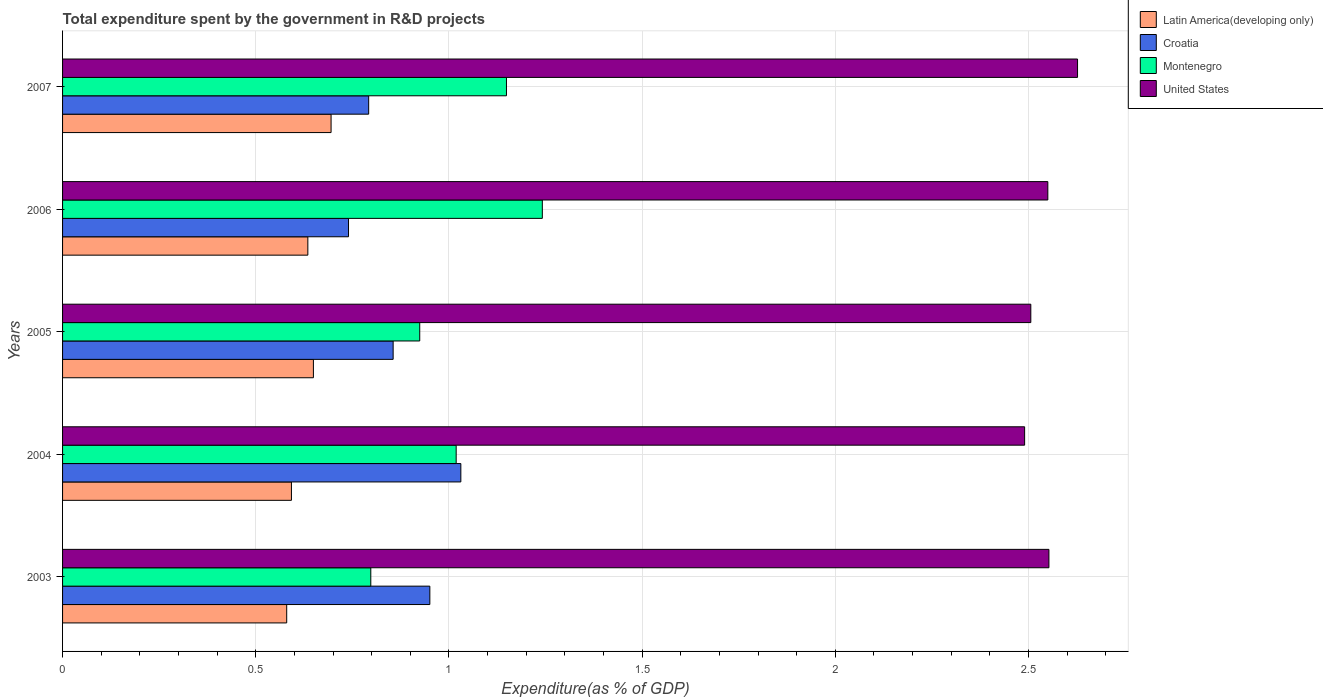How many different coloured bars are there?
Your answer should be compact. 4. How many groups of bars are there?
Provide a short and direct response. 5. Are the number of bars per tick equal to the number of legend labels?
Offer a terse response. Yes. How many bars are there on the 4th tick from the bottom?
Your answer should be compact. 4. In how many cases, is the number of bars for a given year not equal to the number of legend labels?
Provide a succinct answer. 0. What is the total expenditure spent by the government in R&D projects in United States in 2006?
Your answer should be very brief. 2.55. Across all years, what is the maximum total expenditure spent by the government in R&D projects in Croatia?
Give a very brief answer. 1.03. Across all years, what is the minimum total expenditure spent by the government in R&D projects in Croatia?
Make the answer very short. 0.74. In which year was the total expenditure spent by the government in R&D projects in Latin America(developing only) maximum?
Offer a very short reply. 2007. What is the total total expenditure spent by the government in R&D projects in Montenegro in the graph?
Ensure brevity in your answer.  5.13. What is the difference between the total expenditure spent by the government in R&D projects in Latin America(developing only) in 2006 and that in 2007?
Provide a short and direct response. -0.06. What is the difference between the total expenditure spent by the government in R&D projects in Croatia in 2006 and the total expenditure spent by the government in R&D projects in Montenegro in 2003?
Keep it short and to the point. -0.06. What is the average total expenditure spent by the government in R&D projects in Montenegro per year?
Offer a terse response. 1.03. In the year 2006, what is the difference between the total expenditure spent by the government in R&D projects in Latin America(developing only) and total expenditure spent by the government in R&D projects in Montenegro?
Provide a short and direct response. -0.61. What is the ratio of the total expenditure spent by the government in R&D projects in Croatia in 2003 to that in 2006?
Provide a short and direct response. 1.28. Is the difference between the total expenditure spent by the government in R&D projects in Latin America(developing only) in 2004 and 2007 greater than the difference between the total expenditure spent by the government in R&D projects in Montenegro in 2004 and 2007?
Keep it short and to the point. Yes. What is the difference between the highest and the second highest total expenditure spent by the government in R&D projects in Montenegro?
Give a very brief answer. 0.09. What is the difference between the highest and the lowest total expenditure spent by the government in R&D projects in Latin America(developing only)?
Your answer should be very brief. 0.11. In how many years, is the total expenditure spent by the government in R&D projects in Latin America(developing only) greater than the average total expenditure spent by the government in R&D projects in Latin America(developing only) taken over all years?
Ensure brevity in your answer.  3. Is the sum of the total expenditure spent by the government in R&D projects in United States in 2006 and 2007 greater than the maximum total expenditure spent by the government in R&D projects in Montenegro across all years?
Give a very brief answer. Yes. What does the 4th bar from the top in 2004 represents?
Offer a terse response. Latin America(developing only). What does the 3rd bar from the bottom in 2006 represents?
Ensure brevity in your answer.  Montenegro. Is it the case that in every year, the sum of the total expenditure spent by the government in R&D projects in Montenegro and total expenditure spent by the government in R&D projects in Latin America(developing only) is greater than the total expenditure spent by the government in R&D projects in Croatia?
Your answer should be compact. Yes. How many bars are there?
Offer a very short reply. 20. Are all the bars in the graph horizontal?
Give a very brief answer. Yes. How many years are there in the graph?
Provide a succinct answer. 5. Does the graph contain any zero values?
Provide a short and direct response. No. Does the graph contain grids?
Give a very brief answer. Yes. Where does the legend appear in the graph?
Give a very brief answer. Top right. What is the title of the graph?
Make the answer very short. Total expenditure spent by the government in R&D projects. What is the label or title of the X-axis?
Ensure brevity in your answer.  Expenditure(as % of GDP). What is the label or title of the Y-axis?
Your answer should be very brief. Years. What is the Expenditure(as % of GDP) of Latin America(developing only) in 2003?
Your answer should be compact. 0.58. What is the Expenditure(as % of GDP) of Croatia in 2003?
Offer a very short reply. 0.95. What is the Expenditure(as % of GDP) in Montenegro in 2003?
Offer a terse response. 0.8. What is the Expenditure(as % of GDP) in United States in 2003?
Offer a very short reply. 2.55. What is the Expenditure(as % of GDP) of Latin America(developing only) in 2004?
Your response must be concise. 0.59. What is the Expenditure(as % of GDP) of Croatia in 2004?
Make the answer very short. 1.03. What is the Expenditure(as % of GDP) of Montenegro in 2004?
Keep it short and to the point. 1.02. What is the Expenditure(as % of GDP) in United States in 2004?
Give a very brief answer. 2.49. What is the Expenditure(as % of GDP) of Latin America(developing only) in 2005?
Ensure brevity in your answer.  0.65. What is the Expenditure(as % of GDP) in Croatia in 2005?
Make the answer very short. 0.86. What is the Expenditure(as % of GDP) in Montenegro in 2005?
Ensure brevity in your answer.  0.92. What is the Expenditure(as % of GDP) in United States in 2005?
Offer a terse response. 2.51. What is the Expenditure(as % of GDP) of Latin America(developing only) in 2006?
Your response must be concise. 0.63. What is the Expenditure(as % of GDP) in Croatia in 2006?
Offer a terse response. 0.74. What is the Expenditure(as % of GDP) of Montenegro in 2006?
Ensure brevity in your answer.  1.24. What is the Expenditure(as % of GDP) in United States in 2006?
Make the answer very short. 2.55. What is the Expenditure(as % of GDP) in Latin America(developing only) in 2007?
Offer a very short reply. 0.69. What is the Expenditure(as % of GDP) in Croatia in 2007?
Provide a succinct answer. 0.79. What is the Expenditure(as % of GDP) in Montenegro in 2007?
Your answer should be compact. 1.15. What is the Expenditure(as % of GDP) in United States in 2007?
Provide a short and direct response. 2.63. Across all years, what is the maximum Expenditure(as % of GDP) in Latin America(developing only)?
Offer a very short reply. 0.69. Across all years, what is the maximum Expenditure(as % of GDP) in Croatia?
Your response must be concise. 1.03. Across all years, what is the maximum Expenditure(as % of GDP) in Montenegro?
Make the answer very short. 1.24. Across all years, what is the maximum Expenditure(as % of GDP) in United States?
Ensure brevity in your answer.  2.63. Across all years, what is the minimum Expenditure(as % of GDP) in Latin America(developing only)?
Give a very brief answer. 0.58. Across all years, what is the minimum Expenditure(as % of GDP) in Croatia?
Provide a succinct answer. 0.74. Across all years, what is the minimum Expenditure(as % of GDP) in Montenegro?
Ensure brevity in your answer.  0.8. Across all years, what is the minimum Expenditure(as % of GDP) of United States?
Ensure brevity in your answer.  2.49. What is the total Expenditure(as % of GDP) of Latin America(developing only) in the graph?
Your answer should be very brief. 3.15. What is the total Expenditure(as % of GDP) of Croatia in the graph?
Give a very brief answer. 4.37. What is the total Expenditure(as % of GDP) of Montenegro in the graph?
Offer a very short reply. 5.13. What is the total Expenditure(as % of GDP) of United States in the graph?
Your answer should be very brief. 12.73. What is the difference between the Expenditure(as % of GDP) of Latin America(developing only) in 2003 and that in 2004?
Offer a very short reply. -0.01. What is the difference between the Expenditure(as % of GDP) in Croatia in 2003 and that in 2004?
Provide a short and direct response. -0.08. What is the difference between the Expenditure(as % of GDP) in Montenegro in 2003 and that in 2004?
Your answer should be compact. -0.22. What is the difference between the Expenditure(as % of GDP) of United States in 2003 and that in 2004?
Offer a terse response. 0.06. What is the difference between the Expenditure(as % of GDP) in Latin America(developing only) in 2003 and that in 2005?
Keep it short and to the point. -0.07. What is the difference between the Expenditure(as % of GDP) in Croatia in 2003 and that in 2005?
Give a very brief answer. 0.1. What is the difference between the Expenditure(as % of GDP) in Montenegro in 2003 and that in 2005?
Provide a short and direct response. -0.13. What is the difference between the Expenditure(as % of GDP) of United States in 2003 and that in 2005?
Ensure brevity in your answer.  0.05. What is the difference between the Expenditure(as % of GDP) of Latin America(developing only) in 2003 and that in 2006?
Provide a short and direct response. -0.05. What is the difference between the Expenditure(as % of GDP) in Croatia in 2003 and that in 2006?
Provide a short and direct response. 0.21. What is the difference between the Expenditure(as % of GDP) in Montenegro in 2003 and that in 2006?
Provide a succinct answer. -0.44. What is the difference between the Expenditure(as % of GDP) of United States in 2003 and that in 2006?
Make the answer very short. 0. What is the difference between the Expenditure(as % of GDP) of Latin America(developing only) in 2003 and that in 2007?
Provide a short and direct response. -0.11. What is the difference between the Expenditure(as % of GDP) of Croatia in 2003 and that in 2007?
Ensure brevity in your answer.  0.16. What is the difference between the Expenditure(as % of GDP) of Montenegro in 2003 and that in 2007?
Provide a short and direct response. -0.35. What is the difference between the Expenditure(as % of GDP) of United States in 2003 and that in 2007?
Make the answer very short. -0.07. What is the difference between the Expenditure(as % of GDP) in Latin America(developing only) in 2004 and that in 2005?
Your answer should be very brief. -0.06. What is the difference between the Expenditure(as % of GDP) of Croatia in 2004 and that in 2005?
Offer a terse response. 0.18. What is the difference between the Expenditure(as % of GDP) of Montenegro in 2004 and that in 2005?
Your answer should be compact. 0.09. What is the difference between the Expenditure(as % of GDP) in United States in 2004 and that in 2005?
Your answer should be compact. -0.02. What is the difference between the Expenditure(as % of GDP) of Latin America(developing only) in 2004 and that in 2006?
Offer a very short reply. -0.04. What is the difference between the Expenditure(as % of GDP) in Croatia in 2004 and that in 2006?
Your answer should be very brief. 0.29. What is the difference between the Expenditure(as % of GDP) in Montenegro in 2004 and that in 2006?
Give a very brief answer. -0.22. What is the difference between the Expenditure(as % of GDP) in United States in 2004 and that in 2006?
Offer a very short reply. -0.06. What is the difference between the Expenditure(as % of GDP) of Latin America(developing only) in 2004 and that in 2007?
Keep it short and to the point. -0.1. What is the difference between the Expenditure(as % of GDP) in Croatia in 2004 and that in 2007?
Offer a terse response. 0.24. What is the difference between the Expenditure(as % of GDP) of Montenegro in 2004 and that in 2007?
Offer a very short reply. -0.13. What is the difference between the Expenditure(as % of GDP) of United States in 2004 and that in 2007?
Make the answer very short. -0.14. What is the difference between the Expenditure(as % of GDP) of Latin America(developing only) in 2005 and that in 2006?
Your answer should be compact. 0.01. What is the difference between the Expenditure(as % of GDP) in Croatia in 2005 and that in 2006?
Offer a terse response. 0.12. What is the difference between the Expenditure(as % of GDP) in Montenegro in 2005 and that in 2006?
Your answer should be compact. -0.32. What is the difference between the Expenditure(as % of GDP) of United States in 2005 and that in 2006?
Your response must be concise. -0.04. What is the difference between the Expenditure(as % of GDP) in Latin America(developing only) in 2005 and that in 2007?
Make the answer very short. -0.05. What is the difference between the Expenditure(as % of GDP) of Croatia in 2005 and that in 2007?
Your answer should be very brief. 0.06. What is the difference between the Expenditure(as % of GDP) in Montenegro in 2005 and that in 2007?
Make the answer very short. -0.22. What is the difference between the Expenditure(as % of GDP) of United States in 2005 and that in 2007?
Provide a short and direct response. -0.12. What is the difference between the Expenditure(as % of GDP) of Latin America(developing only) in 2006 and that in 2007?
Keep it short and to the point. -0.06. What is the difference between the Expenditure(as % of GDP) in Croatia in 2006 and that in 2007?
Keep it short and to the point. -0.05. What is the difference between the Expenditure(as % of GDP) of Montenegro in 2006 and that in 2007?
Provide a short and direct response. 0.09. What is the difference between the Expenditure(as % of GDP) of United States in 2006 and that in 2007?
Provide a short and direct response. -0.08. What is the difference between the Expenditure(as % of GDP) of Latin America(developing only) in 2003 and the Expenditure(as % of GDP) of Croatia in 2004?
Keep it short and to the point. -0.45. What is the difference between the Expenditure(as % of GDP) in Latin America(developing only) in 2003 and the Expenditure(as % of GDP) in Montenegro in 2004?
Offer a terse response. -0.44. What is the difference between the Expenditure(as % of GDP) of Latin America(developing only) in 2003 and the Expenditure(as % of GDP) of United States in 2004?
Provide a succinct answer. -1.91. What is the difference between the Expenditure(as % of GDP) of Croatia in 2003 and the Expenditure(as % of GDP) of Montenegro in 2004?
Offer a very short reply. -0.07. What is the difference between the Expenditure(as % of GDP) in Croatia in 2003 and the Expenditure(as % of GDP) in United States in 2004?
Your answer should be compact. -1.54. What is the difference between the Expenditure(as % of GDP) in Montenegro in 2003 and the Expenditure(as % of GDP) in United States in 2004?
Provide a short and direct response. -1.69. What is the difference between the Expenditure(as % of GDP) in Latin America(developing only) in 2003 and the Expenditure(as % of GDP) in Croatia in 2005?
Make the answer very short. -0.28. What is the difference between the Expenditure(as % of GDP) of Latin America(developing only) in 2003 and the Expenditure(as % of GDP) of Montenegro in 2005?
Your response must be concise. -0.34. What is the difference between the Expenditure(as % of GDP) in Latin America(developing only) in 2003 and the Expenditure(as % of GDP) in United States in 2005?
Keep it short and to the point. -1.93. What is the difference between the Expenditure(as % of GDP) in Croatia in 2003 and the Expenditure(as % of GDP) in Montenegro in 2005?
Make the answer very short. 0.03. What is the difference between the Expenditure(as % of GDP) of Croatia in 2003 and the Expenditure(as % of GDP) of United States in 2005?
Your answer should be very brief. -1.56. What is the difference between the Expenditure(as % of GDP) in Montenegro in 2003 and the Expenditure(as % of GDP) in United States in 2005?
Your response must be concise. -1.71. What is the difference between the Expenditure(as % of GDP) of Latin America(developing only) in 2003 and the Expenditure(as % of GDP) of Croatia in 2006?
Your answer should be compact. -0.16. What is the difference between the Expenditure(as % of GDP) of Latin America(developing only) in 2003 and the Expenditure(as % of GDP) of Montenegro in 2006?
Make the answer very short. -0.66. What is the difference between the Expenditure(as % of GDP) in Latin America(developing only) in 2003 and the Expenditure(as % of GDP) in United States in 2006?
Keep it short and to the point. -1.97. What is the difference between the Expenditure(as % of GDP) of Croatia in 2003 and the Expenditure(as % of GDP) of Montenegro in 2006?
Provide a short and direct response. -0.29. What is the difference between the Expenditure(as % of GDP) in Croatia in 2003 and the Expenditure(as % of GDP) in United States in 2006?
Keep it short and to the point. -1.6. What is the difference between the Expenditure(as % of GDP) of Montenegro in 2003 and the Expenditure(as % of GDP) of United States in 2006?
Ensure brevity in your answer.  -1.75. What is the difference between the Expenditure(as % of GDP) of Latin America(developing only) in 2003 and the Expenditure(as % of GDP) of Croatia in 2007?
Give a very brief answer. -0.21. What is the difference between the Expenditure(as % of GDP) in Latin America(developing only) in 2003 and the Expenditure(as % of GDP) in Montenegro in 2007?
Give a very brief answer. -0.57. What is the difference between the Expenditure(as % of GDP) in Latin America(developing only) in 2003 and the Expenditure(as % of GDP) in United States in 2007?
Offer a very short reply. -2.05. What is the difference between the Expenditure(as % of GDP) in Croatia in 2003 and the Expenditure(as % of GDP) in Montenegro in 2007?
Provide a succinct answer. -0.2. What is the difference between the Expenditure(as % of GDP) of Croatia in 2003 and the Expenditure(as % of GDP) of United States in 2007?
Keep it short and to the point. -1.68. What is the difference between the Expenditure(as % of GDP) in Montenegro in 2003 and the Expenditure(as % of GDP) in United States in 2007?
Provide a succinct answer. -1.83. What is the difference between the Expenditure(as % of GDP) in Latin America(developing only) in 2004 and the Expenditure(as % of GDP) in Croatia in 2005?
Provide a succinct answer. -0.26. What is the difference between the Expenditure(as % of GDP) of Latin America(developing only) in 2004 and the Expenditure(as % of GDP) of Montenegro in 2005?
Offer a terse response. -0.33. What is the difference between the Expenditure(as % of GDP) in Latin America(developing only) in 2004 and the Expenditure(as % of GDP) in United States in 2005?
Your response must be concise. -1.91. What is the difference between the Expenditure(as % of GDP) in Croatia in 2004 and the Expenditure(as % of GDP) in Montenegro in 2005?
Give a very brief answer. 0.11. What is the difference between the Expenditure(as % of GDP) of Croatia in 2004 and the Expenditure(as % of GDP) of United States in 2005?
Offer a very short reply. -1.48. What is the difference between the Expenditure(as % of GDP) in Montenegro in 2004 and the Expenditure(as % of GDP) in United States in 2005?
Your answer should be compact. -1.49. What is the difference between the Expenditure(as % of GDP) of Latin America(developing only) in 2004 and the Expenditure(as % of GDP) of Croatia in 2006?
Your answer should be compact. -0.15. What is the difference between the Expenditure(as % of GDP) of Latin America(developing only) in 2004 and the Expenditure(as % of GDP) of Montenegro in 2006?
Keep it short and to the point. -0.65. What is the difference between the Expenditure(as % of GDP) in Latin America(developing only) in 2004 and the Expenditure(as % of GDP) in United States in 2006?
Keep it short and to the point. -1.96. What is the difference between the Expenditure(as % of GDP) of Croatia in 2004 and the Expenditure(as % of GDP) of Montenegro in 2006?
Ensure brevity in your answer.  -0.21. What is the difference between the Expenditure(as % of GDP) in Croatia in 2004 and the Expenditure(as % of GDP) in United States in 2006?
Your answer should be compact. -1.52. What is the difference between the Expenditure(as % of GDP) of Montenegro in 2004 and the Expenditure(as % of GDP) of United States in 2006?
Give a very brief answer. -1.53. What is the difference between the Expenditure(as % of GDP) in Latin America(developing only) in 2004 and the Expenditure(as % of GDP) in Croatia in 2007?
Provide a succinct answer. -0.2. What is the difference between the Expenditure(as % of GDP) of Latin America(developing only) in 2004 and the Expenditure(as % of GDP) of Montenegro in 2007?
Keep it short and to the point. -0.56. What is the difference between the Expenditure(as % of GDP) of Latin America(developing only) in 2004 and the Expenditure(as % of GDP) of United States in 2007?
Your answer should be compact. -2.03. What is the difference between the Expenditure(as % of GDP) of Croatia in 2004 and the Expenditure(as % of GDP) of Montenegro in 2007?
Make the answer very short. -0.12. What is the difference between the Expenditure(as % of GDP) of Croatia in 2004 and the Expenditure(as % of GDP) of United States in 2007?
Your answer should be compact. -1.6. What is the difference between the Expenditure(as % of GDP) of Montenegro in 2004 and the Expenditure(as % of GDP) of United States in 2007?
Ensure brevity in your answer.  -1.61. What is the difference between the Expenditure(as % of GDP) of Latin America(developing only) in 2005 and the Expenditure(as % of GDP) of Croatia in 2006?
Offer a very short reply. -0.09. What is the difference between the Expenditure(as % of GDP) in Latin America(developing only) in 2005 and the Expenditure(as % of GDP) in Montenegro in 2006?
Your answer should be compact. -0.59. What is the difference between the Expenditure(as % of GDP) in Latin America(developing only) in 2005 and the Expenditure(as % of GDP) in United States in 2006?
Make the answer very short. -1.9. What is the difference between the Expenditure(as % of GDP) of Croatia in 2005 and the Expenditure(as % of GDP) of Montenegro in 2006?
Offer a very short reply. -0.39. What is the difference between the Expenditure(as % of GDP) of Croatia in 2005 and the Expenditure(as % of GDP) of United States in 2006?
Make the answer very short. -1.69. What is the difference between the Expenditure(as % of GDP) in Montenegro in 2005 and the Expenditure(as % of GDP) in United States in 2006?
Ensure brevity in your answer.  -1.63. What is the difference between the Expenditure(as % of GDP) in Latin America(developing only) in 2005 and the Expenditure(as % of GDP) in Croatia in 2007?
Offer a terse response. -0.14. What is the difference between the Expenditure(as % of GDP) of Latin America(developing only) in 2005 and the Expenditure(as % of GDP) of Montenegro in 2007?
Provide a short and direct response. -0.5. What is the difference between the Expenditure(as % of GDP) of Latin America(developing only) in 2005 and the Expenditure(as % of GDP) of United States in 2007?
Your answer should be compact. -1.98. What is the difference between the Expenditure(as % of GDP) in Croatia in 2005 and the Expenditure(as % of GDP) in Montenegro in 2007?
Offer a very short reply. -0.29. What is the difference between the Expenditure(as % of GDP) in Croatia in 2005 and the Expenditure(as % of GDP) in United States in 2007?
Your answer should be compact. -1.77. What is the difference between the Expenditure(as % of GDP) in Montenegro in 2005 and the Expenditure(as % of GDP) in United States in 2007?
Your response must be concise. -1.7. What is the difference between the Expenditure(as % of GDP) in Latin America(developing only) in 2006 and the Expenditure(as % of GDP) in Croatia in 2007?
Keep it short and to the point. -0.16. What is the difference between the Expenditure(as % of GDP) of Latin America(developing only) in 2006 and the Expenditure(as % of GDP) of Montenegro in 2007?
Ensure brevity in your answer.  -0.51. What is the difference between the Expenditure(as % of GDP) in Latin America(developing only) in 2006 and the Expenditure(as % of GDP) in United States in 2007?
Keep it short and to the point. -1.99. What is the difference between the Expenditure(as % of GDP) of Croatia in 2006 and the Expenditure(as % of GDP) of Montenegro in 2007?
Make the answer very short. -0.41. What is the difference between the Expenditure(as % of GDP) in Croatia in 2006 and the Expenditure(as % of GDP) in United States in 2007?
Your answer should be very brief. -1.89. What is the difference between the Expenditure(as % of GDP) in Montenegro in 2006 and the Expenditure(as % of GDP) in United States in 2007?
Your response must be concise. -1.39. What is the average Expenditure(as % of GDP) of Latin America(developing only) per year?
Offer a terse response. 0.63. What is the average Expenditure(as % of GDP) in Croatia per year?
Your response must be concise. 0.87. What is the average Expenditure(as % of GDP) of Montenegro per year?
Provide a short and direct response. 1.03. What is the average Expenditure(as % of GDP) in United States per year?
Keep it short and to the point. 2.55. In the year 2003, what is the difference between the Expenditure(as % of GDP) of Latin America(developing only) and Expenditure(as % of GDP) of Croatia?
Offer a very short reply. -0.37. In the year 2003, what is the difference between the Expenditure(as % of GDP) of Latin America(developing only) and Expenditure(as % of GDP) of Montenegro?
Offer a terse response. -0.22. In the year 2003, what is the difference between the Expenditure(as % of GDP) in Latin America(developing only) and Expenditure(as % of GDP) in United States?
Offer a terse response. -1.97. In the year 2003, what is the difference between the Expenditure(as % of GDP) of Croatia and Expenditure(as % of GDP) of Montenegro?
Your answer should be compact. 0.15. In the year 2003, what is the difference between the Expenditure(as % of GDP) of Croatia and Expenditure(as % of GDP) of United States?
Your answer should be compact. -1.6. In the year 2003, what is the difference between the Expenditure(as % of GDP) of Montenegro and Expenditure(as % of GDP) of United States?
Your answer should be very brief. -1.76. In the year 2004, what is the difference between the Expenditure(as % of GDP) in Latin America(developing only) and Expenditure(as % of GDP) in Croatia?
Your response must be concise. -0.44. In the year 2004, what is the difference between the Expenditure(as % of GDP) of Latin America(developing only) and Expenditure(as % of GDP) of Montenegro?
Offer a terse response. -0.43. In the year 2004, what is the difference between the Expenditure(as % of GDP) in Latin America(developing only) and Expenditure(as % of GDP) in United States?
Make the answer very short. -1.9. In the year 2004, what is the difference between the Expenditure(as % of GDP) of Croatia and Expenditure(as % of GDP) of Montenegro?
Make the answer very short. 0.01. In the year 2004, what is the difference between the Expenditure(as % of GDP) in Croatia and Expenditure(as % of GDP) in United States?
Offer a very short reply. -1.46. In the year 2004, what is the difference between the Expenditure(as % of GDP) in Montenegro and Expenditure(as % of GDP) in United States?
Your response must be concise. -1.47. In the year 2005, what is the difference between the Expenditure(as % of GDP) of Latin America(developing only) and Expenditure(as % of GDP) of Croatia?
Provide a succinct answer. -0.21. In the year 2005, what is the difference between the Expenditure(as % of GDP) of Latin America(developing only) and Expenditure(as % of GDP) of Montenegro?
Keep it short and to the point. -0.28. In the year 2005, what is the difference between the Expenditure(as % of GDP) of Latin America(developing only) and Expenditure(as % of GDP) of United States?
Provide a short and direct response. -1.86. In the year 2005, what is the difference between the Expenditure(as % of GDP) in Croatia and Expenditure(as % of GDP) in Montenegro?
Provide a succinct answer. -0.07. In the year 2005, what is the difference between the Expenditure(as % of GDP) of Croatia and Expenditure(as % of GDP) of United States?
Your response must be concise. -1.65. In the year 2005, what is the difference between the Expenditure(as % of GDP) in Montenegro and Expenditure(as % of GDP) in United States?
Your response must be concise. -1.58. In the year 2006, what is the difference between the Expenditure(as % of GDP) in Latin America(developing only) and Expenditure(as % of GDP) in Croatia?
Your answer should be compact. -0.11. In the year 2006, what is the difference between the Expenditure(as % of GDP) of Latin America(developing only) and Expenditure(as % of GDP) of Montenegro?
Ensure brevity in your answer.  -0.61. In the year 2006, what is the difference between the Expenditure(as % of GDP) in Latin America(developing only) and Expenditure(as % of GDP) in United States?
Make the answer very short. -1.92. In the year 2006, what is the difference between the Expenditure(as % of GDP) in Croatia and Expenditure(as % of GDP) in Montenegro?
Offer a very short reply. -0.5. In the year 2006, what is the difference between the Expenditure(as % of GDP) of Croatia and Expenditure(as % of GDP) of United States?
Offer a terse response. -1.81. In the year 2006, what is the difference between the Expenditure(as % of GDP) of Montenegro and Expenditure(as % of GDP) of United States?
Keep it short and to the point. -1.31. In the year 2007, what is the difference between the Expenditure(as % of GDP) of Latin America(developing only) and Expenditure(as % of GDP) of Croatia?
Keep it short and to the point. -0.1. In the year 2007, what is the difference between the Expenditure(as % of GDP) in Latin America(developing only) and Expenditure(as % of GDP) in Montenegro?
Ensure brevity in your answer.  -0.45. In the year 2007, what is the difference between the Expenditure(as % of GDP) of Latin America(developing only) and Expenditure(as % of GDP) of United States?
Ensure brevity in your answer.  -1.93. In the year 2007, what is the difference between the Expenditure(as % of GDP) in Croatia and Expenditure(as % of GDP) in Montenegro?
Ensure brevity in your answer.  -0.36. In the year 2007, what is the difference between the Expenditure(as % of GDP) in Croatia and Expenditure(as % of GDP) in United States?
Your response must be concise. -1.83. In the year 2007, what is the difference between the Expenditure(as % of GDP) in Montenegro and Expenditure(as % of GDP) in United States?
Provide a short and direct response. -1.48. What is the ratio of the Expenditure(as % of GDP) of Latin America(developing only) in 2003 to that in 2004?
Provide a succinct answer. 0.98. What is the ratio of the Expenditure(as % of GDP) in Croatia in 2003 to that in 2004?
Keep it short and to the point. 0.92. What is the ratio of the Expenditure(as % of GDP) of Montenegro in 2003 to that in 2004?
Provide a succinct answer. 0.78. What is the ratio of the Expenditure(as % of GDP) of United States in 2003 to that in 2004?
Your answer should be compact. 1.03. What is the ratio of the Expenditure(as % of GDP) of Latin America(developing only) in 2003 to that in 2005?
Make the answer very short. 0.89. What is the ratio of the Expenditure(as % of GDP) in Croatia in 2003 to that in 2005?
Give a very brief answer. 1.11. What is the ratio of the Expenditure(as % of GDP) of Montenegro in 2003 to that in 2005?
Offer a very short reply. 0.86. What is the ratio of the Expenditure(as % of GDP) in United States in 2003 to that in 2005?
Provide a succinct answer. 1.02. What is the ratio of the Expenditure(as % of GDP) of Latin America(developing only) in 2003 to that in 2006?
Ensure brevity in your answer.  0.91. What is the ratio of the Expenditure(as % of GDP) of Croatia in 2003 to that in 2006?
Your answer should be very brief. 1.28. What is the ratio of the Expenditure(as % of GDP) in Montenegro in 2003 to that in 2006?
Keep it short and to the point. 0.64. What is the ratio of the Expenditure(as % of GDP) in Latin America(developing only) in 2003 to that in 2007?
Offer a very short reply. 0.83. What is the ratio of the Expenditure(as % of GDP) in Croatia in 2003 to that in 2007?
Offer a terse response. 1.2. What is the ratio of the Expenditure(as % of GDP) of Montenegro in 2003 to that in 2007?
Provide a succinct answer. 0.69. What is the ratio of the Expenditure(as % of GDP) in United States in 2003 to that in 2007?
Your answer should be compact. 0.97. What is the ratio of the Expenditure(as % of GDP) of Latin America(developing only) in 2004 to that in 2005?
Your answer should be very brief. 0.91. What is the ratio of the Expenditure(as % of GDP) in Croatia in 2004 to that in 2005?
Ensure brevity in your answer.  1.2. What is the ratio of the Expenditure(as % of GDP) of Montenegro in 2004 to that in 2005?
Make the answer very short. 1.1. What is the ratio of the Expenditure(as % of GDP) in Latin America(developing only) in 2004 to that in 2006?
Offer a terse response. 0.93. What is the ratio of the Expenditure(as % of GDP) in Croatia in 2004 to that in 2006?
Keep it short and to the point. 1.39. What is the ratio of the Expenditure(as % of GDP) in Montenegro in 2004 to that in 2006?
Your answer should be compact. 0.82. What is the ratio of the Expenditure(as % of GDP) of United States in 2004 to that in 2006?
Provide a succinct answer. 0.98. What is the ratio of the Expenditure(as % of GDP) of Latin America(developing only) in 2004 to that in 2007?
Your answer should be very brief. 0.85. What is the ratio of the Expenditure(as % of GDP) of Croatia in 2004 to that in 2007?
Your answer should be very brief. 1.3. What is the ratio of the Expenditure(as % of GDP) in Montenegro in 2004 to that in 2007?
Offer a very short reply. 0.89. What is the ratio of the Expenditure(as % of GDP) of United States in 2004 to that in 2007?
Keep it short and to the point. 0.95. What is the ratio of the Expenditure(as % of GDP) of Latin America(developing only) in 2005 to that in 2006?
Your answer should be compact. 1.02. What is the ratio of the Expenditure(as % of GDP) of Croatia in 2005 to that in 2006?
Your answer should be compact. 1.16. What is the ratio of the Expenditure(as % of GDP) in Montenegro in 2005 to that in 2006?
Provide a short and direct response. 0.74. What is the ratio of the Expenditure(as % of GDP) of United States in 2005 to that in 2006?
Give a very brief answer. 0.98. What is the ratio of the Expenditure(as % of GDP) in Latin America(developing only) in 2005 to that in 2007?
Offer a very short reply. 0.93. What is the ratio of the Expenditure(as % of GDP) in Croatia in 2005 to that in 2007?
Give a very brief answer. 1.08. What is the ratio of the Expenditure(as % of GDP) in Montenegro in 2005 to that in 2007?
Offer a terse response. 0.8. What is the ratio of the Expenditure(as % of GDP) in United States in 2005 to that in 2007?
Give a very brief answer. 0.95. What is the ratio of the Expenditure(as % of GDP) of Latin America(developing only) in 2006 to that in 2007?
Make the answer very short. 0.91. What is the ratio of the Expenditure(as % of GDP) in Croatia in 2006 to that in 2007?
Offer a terse response. 0.93. What is the ratio of the Expenditure(as % of GDP) in Montenegro in 2006 to that in 2007?
Your answer should be very brief. 1.08. What is the ratio of the Expenditure(as % of GDP) in United States in 2006 to that in 2007?
Offer a terse response. 0.97. What is the difference between the highest and the second highest Expenditure(as % of GDP) of Latin America(developing only)?
Your answer should be very brief. 0.05. What is the difference between the highest and the second highest Expenditure(as % of GDP) of Croatia?
Your answer should be compact. 0.08. What is the difference between the highest and the second highest Expenditure(as % of GDP) of Montenegro?
Provide a succinct answer. 0.09. What is the difference between the highest and the second highest Expenditure(as % of GDP) in United States?
Provide a succinct answer. 0.07. What is the difference between the highest and the lowest Expenditure(as % of GDP) of Latin America(developing only)?
Your answer should be compact. 0.11. What is the difference between the highest and the lowest Expenditure(as % of GDP) in Croatia?
Make the answer very short. 0.29. What is the difference between the highest and the lowest Expenditure(as % of GDP) of Montenegro?
Provide a short and direct response. 0.44. What is the difference between the highest and the lowest Expenditure(as % of GDP) in United States?
Provide a succinct answer. 0.14. 